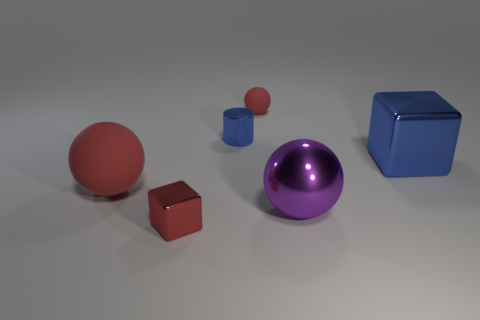Add 4 small green rubber blocks. How many objects exist? 10 Subtract all blocks. How many objects are left? 4 Subtract 1 purple spheres. How many objects are left? 5 Subtract all tiny gray rubber cylinders. Subtract all shiny spheres. How many objects are left? 5 Add 4 large things. How many large things are left? 7 Add 4 big red balls. How many big red balls exist? 5 